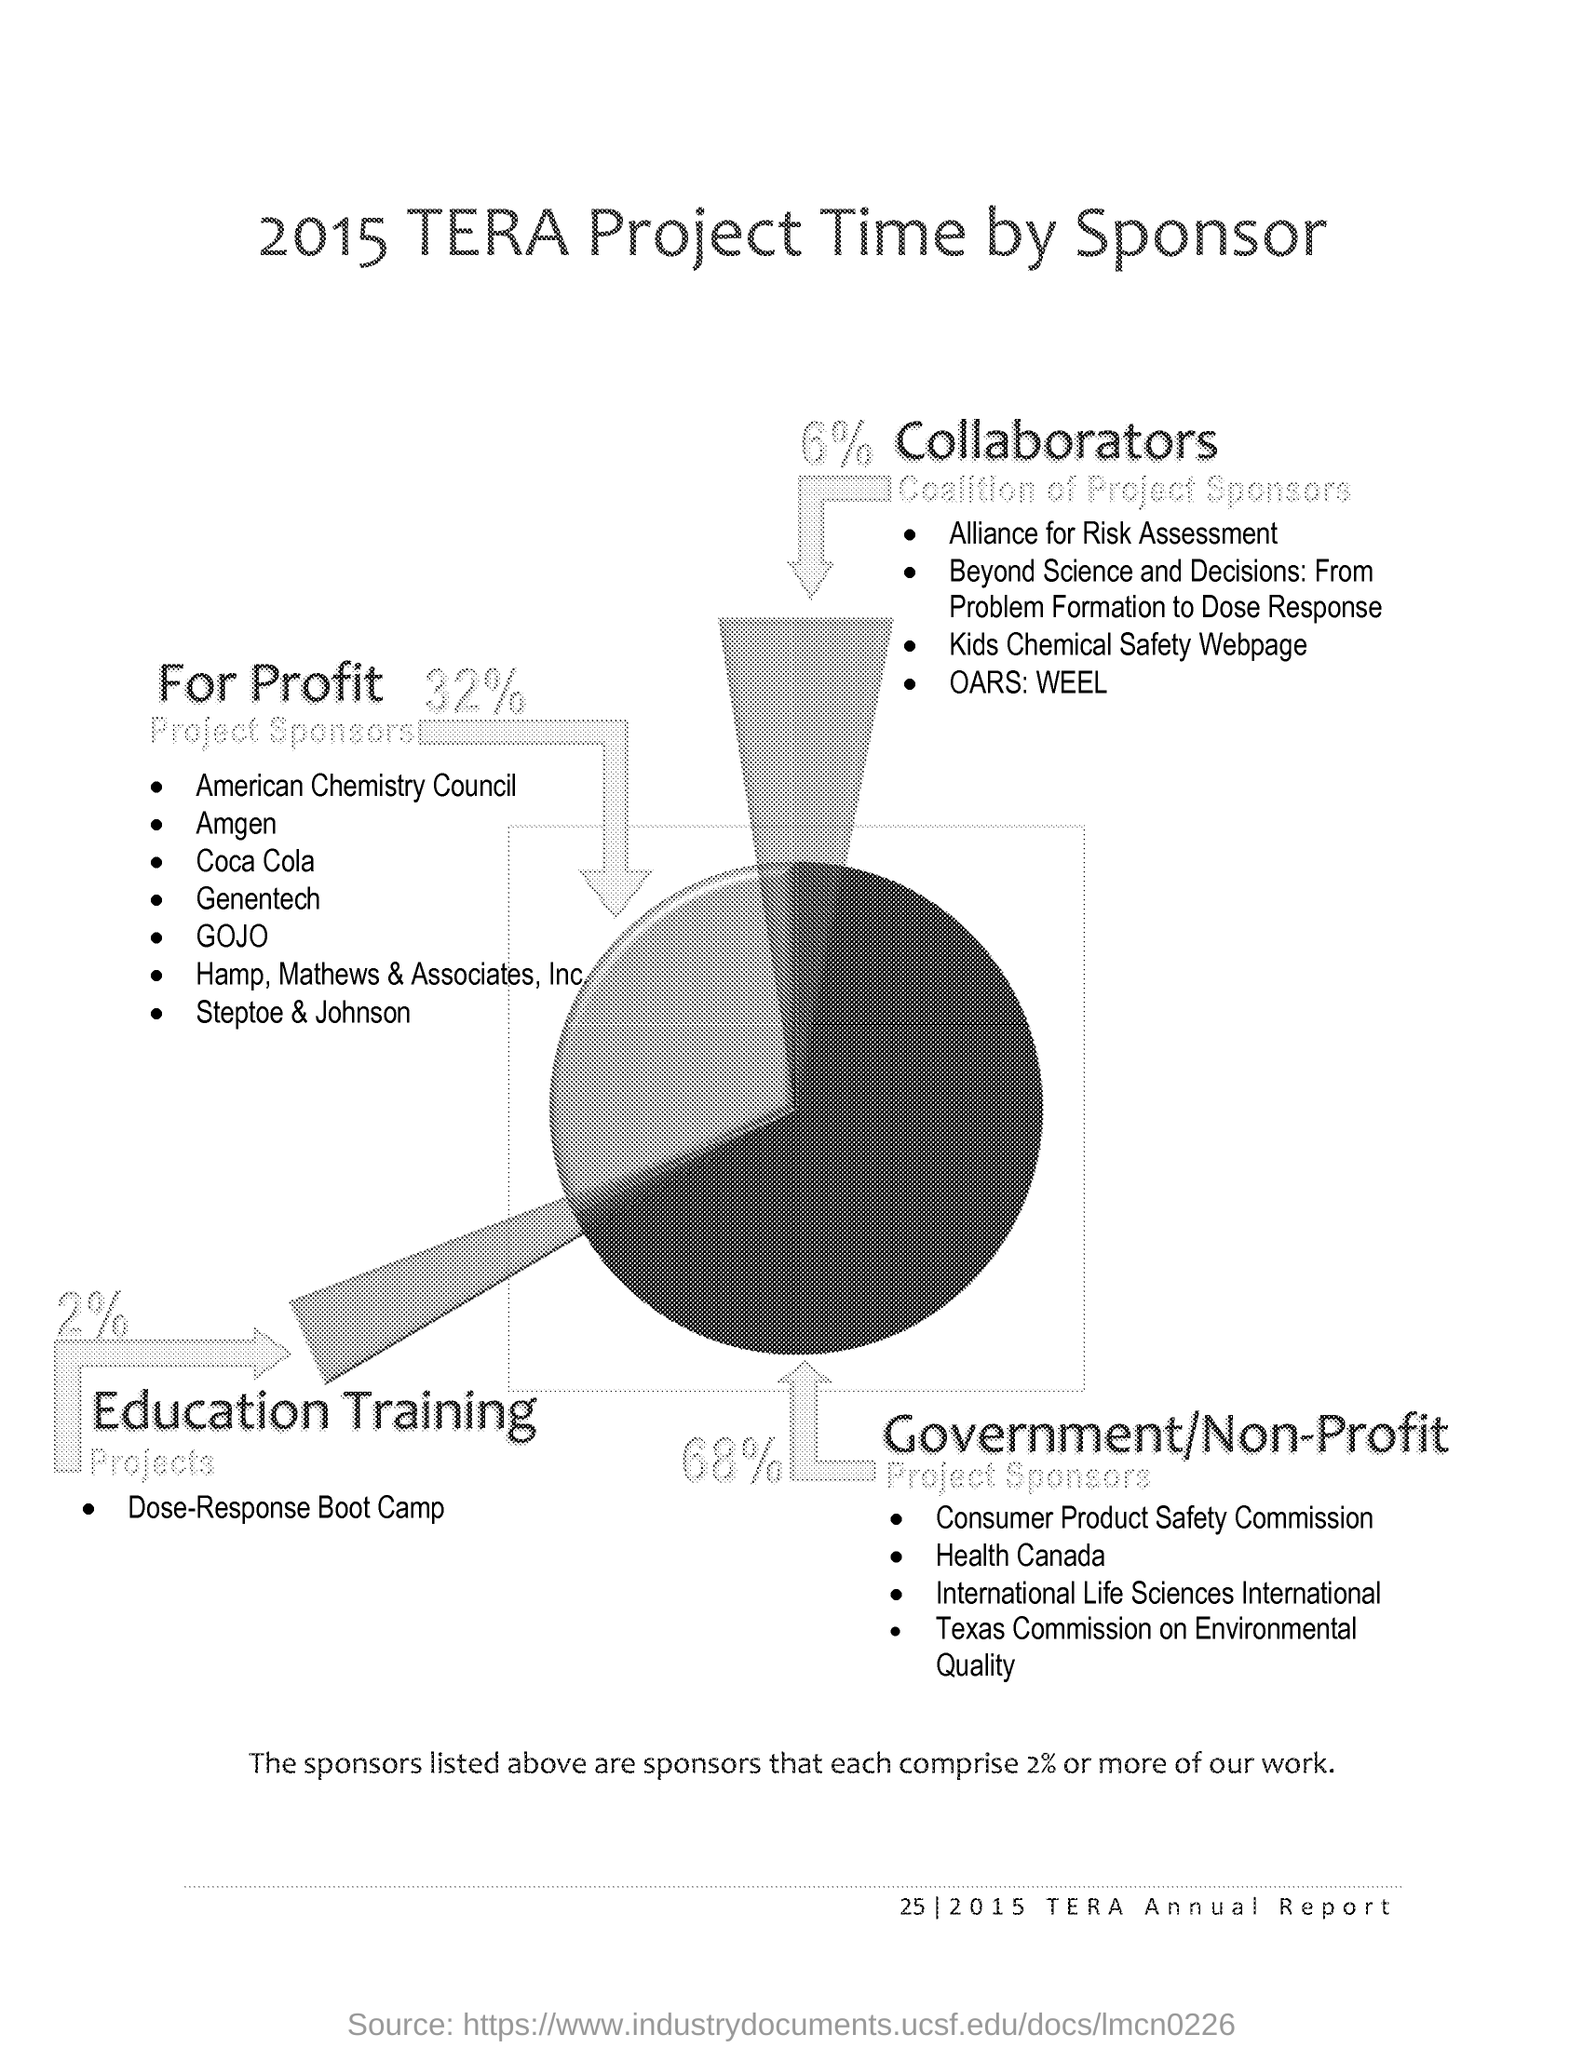How much percentage of the work do the sponsors in the list comprise of?
Make the answer very short. 2% or more. What is the percentage of Government/Non-Profit project sponsors?
Make the answer very short. 68%. What is the percentage of For Profit Project Sponsors?
Your answer should be very brief. 32%. Which one is the first for profit sponsor listed?
Offer a terse response. AMERICAN CHEMISTRY COUNCIL. Coca cola is under which category of sponsors?
Provide a short and direct response. For Profit. 